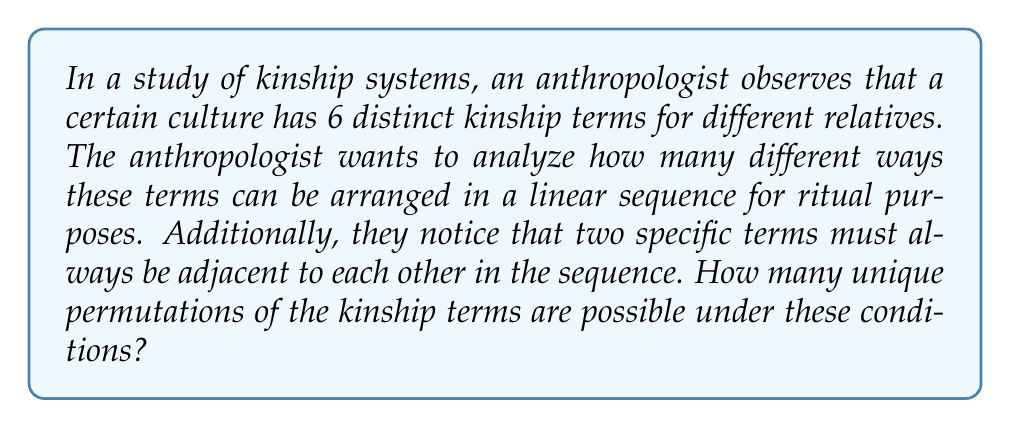Can you answer this question? Let's approach this step-by-step:

1) First, we need to consider the total number of kinship terms. There are 6 distinct terms.

2) However, two specific terms must always be adjacent. We can treat these two terms as a single unit. This effectively reduces our problem to arranging 5 elements (4 individual terms and 1 pair).

3) The number of permutations of n distinct objects is given by n!. In this case, we have 5 elements to arrange.

4) So, the number of permutations of these 5 elements is:

   $$5! = 5 \times 4 \times 3 \times 2 \times 1 = 120$$

5) However, we're not done yet. Remember that the pair of terms that must be adjacent can also be arranged in two ways (term A before term B, or term B before term A).

6) Therefore, we need to multiply our result by 2:

   $$120 \times 2 = 240$$

This accounts for all possible arrangements where the two specific terms are always adjacent, but can be in either order relative to each other.
Answer: 240 unique permutations 